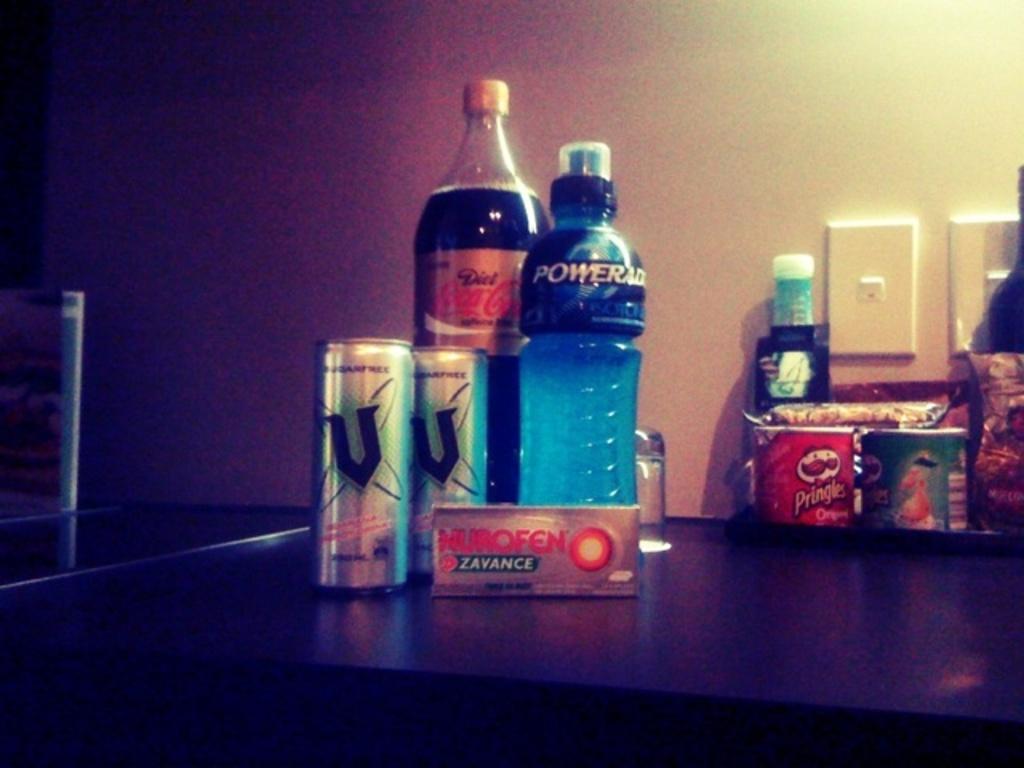What is the blue drink called?
Make the answer very short. Powerade. Is that pringles i am seeing?
Keep it short and to the point. Yes. 